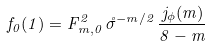<formula> <loc_0><loc_0><loc_500><loc_500>f _ { 0 } ( 1 ) = F _ { m , 0 } ^ { 2 } \, \mathring { \sigma } ^ { - m / 2 } \, \frac { j _ { \phi } ( m ) } { 8 - m }</formula> 